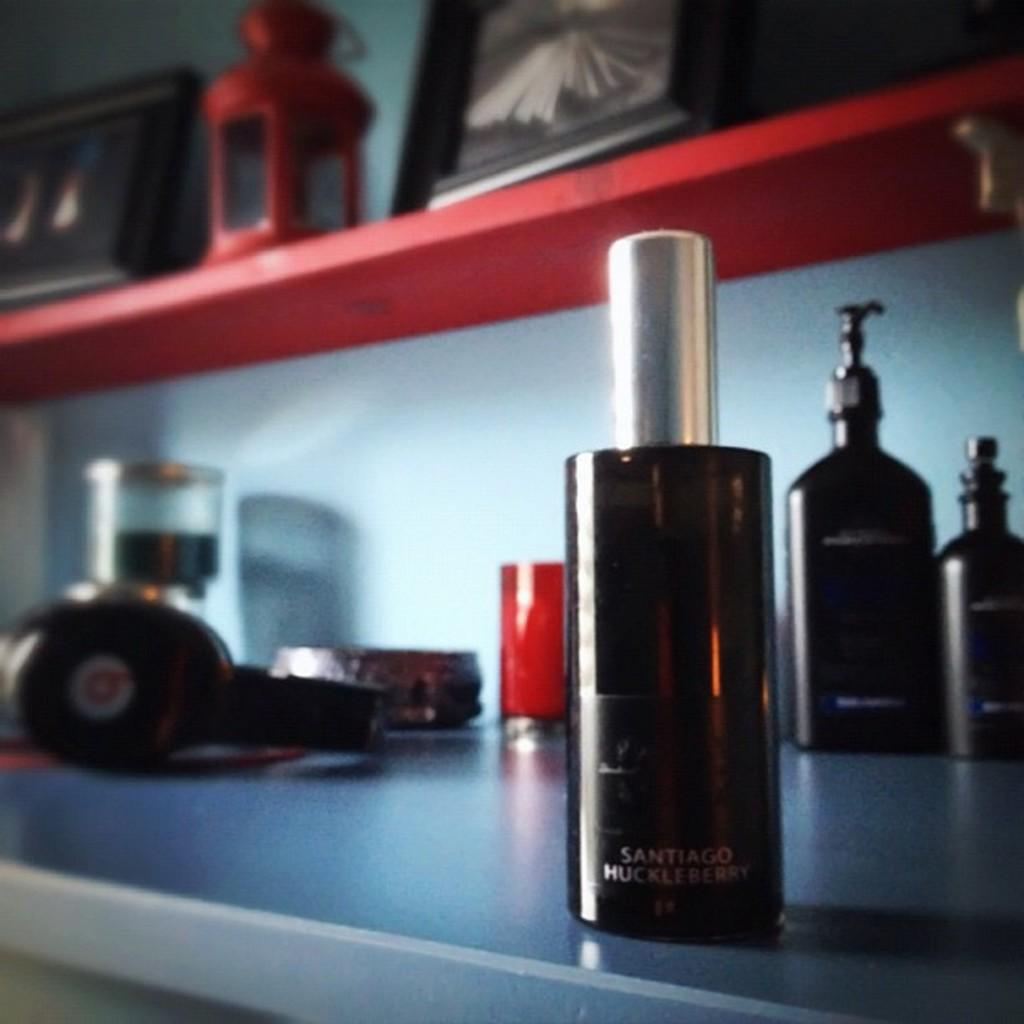<image>
Present a compact description of the photo's key features. A dark amber bottle of Santiago Huckleberry  in the foreground. 